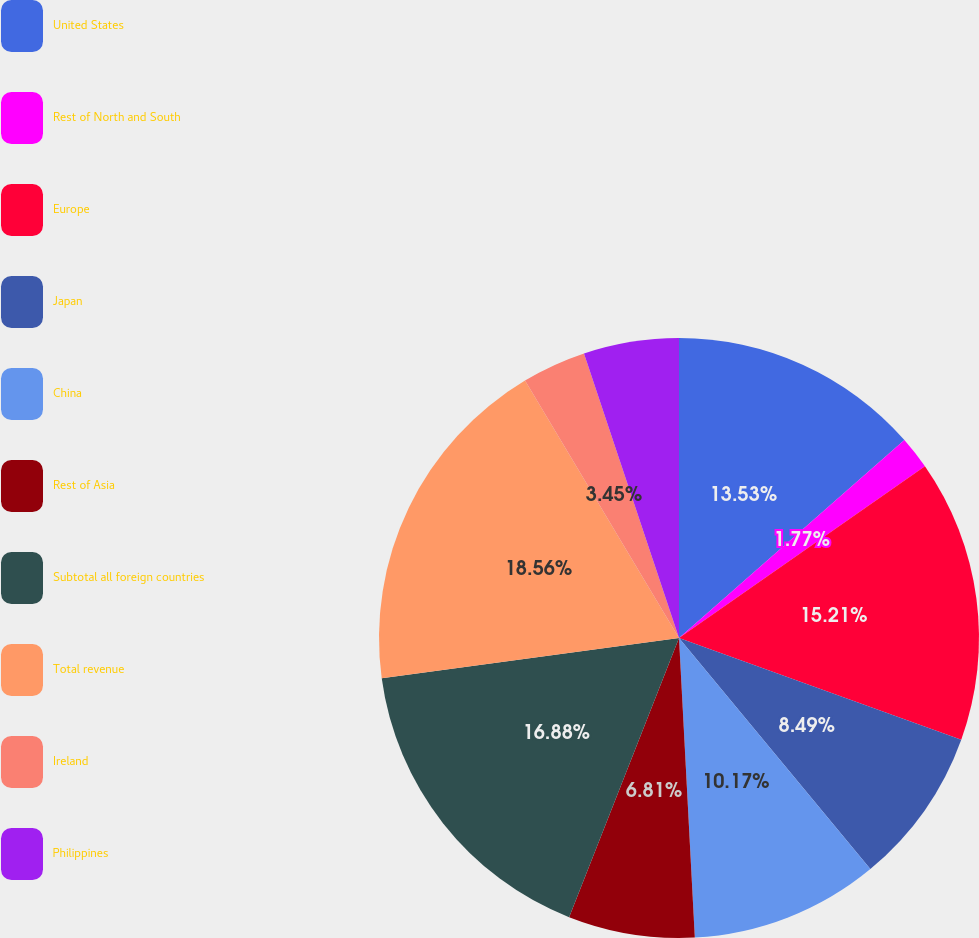<chart> <loc_0><loc_0><loc_500><loc_500><pie_chart><fcel>United States<fcel>Rest of North and South<fcel>Europe<fcel>Japan<fcel>China<fcel>Rest of Asia<fcel>Subtotal all foreign countries<fcel>Total revenue<fcel>Ireland<fcel>Philippines<nl><fcel>13.53%<fcel>1.77%<fcel>15.21%<fcel>8.49%<fcel>10.17%<fcel>6.81%<fcel>16.89%<fcel>18.57%<fcel>3.45%<fcel>5.13%<nl></chart> 